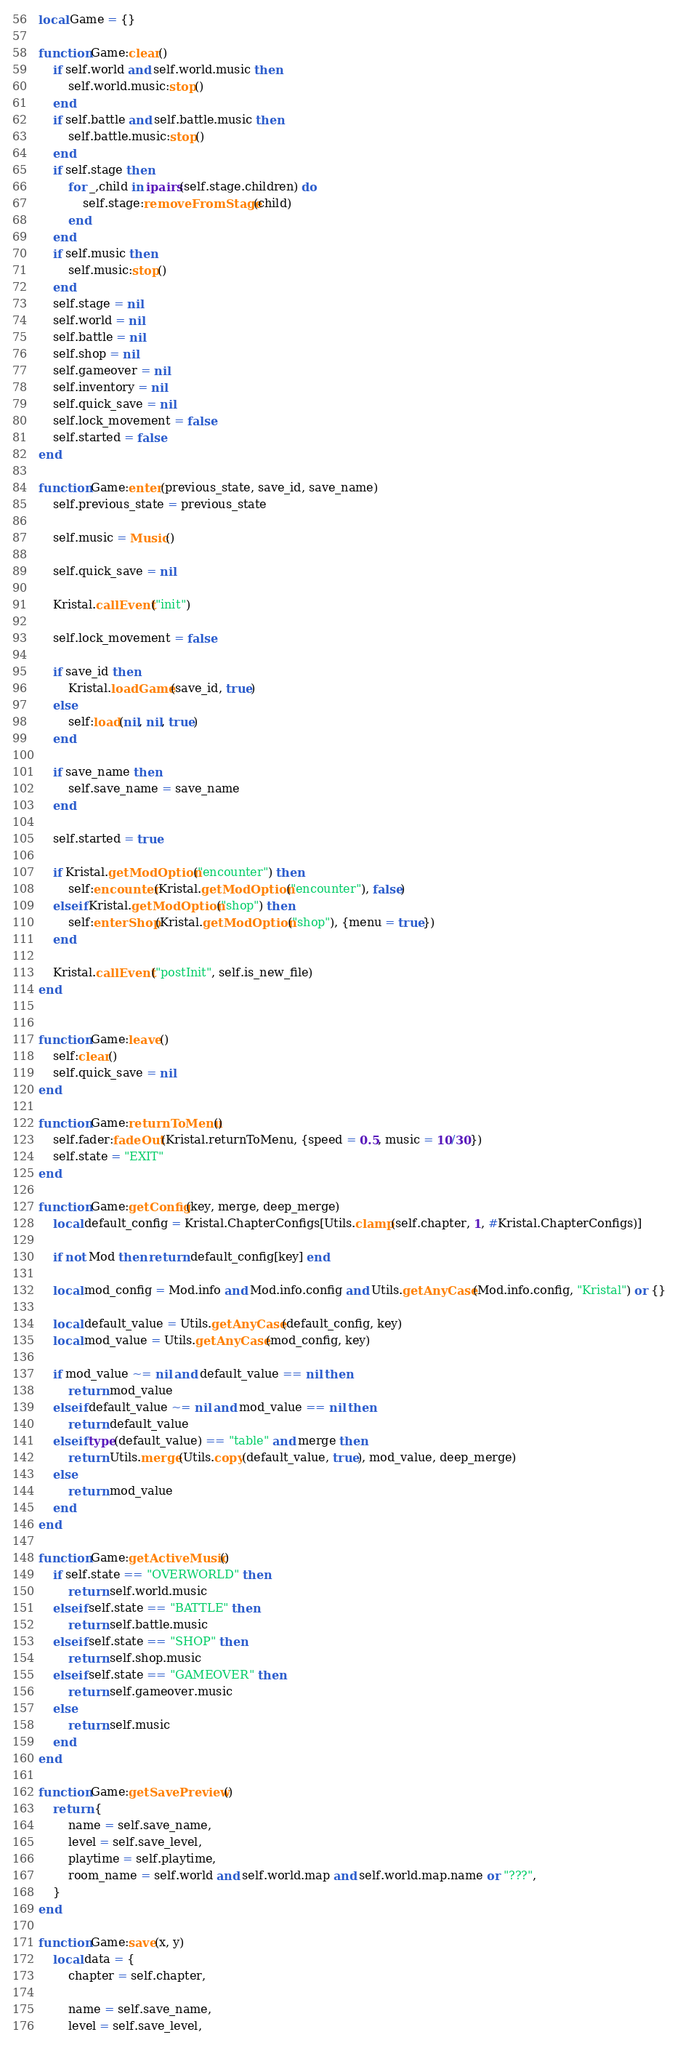<code> <loc_0><loc_0><loc_500><loc_500><_Lua_>local Game = {}

function Game:clear()
    if self.world and self.world.music then
        self.world.music:stop()
    end
    if self.battle and self.battle.music then
        self.battle.music:stop()
    end
    if self.stage then
        for _,child in ipairs(self.stage.children) do
            self.stage:removeFromStage(child)
        end
    end
    if self.music then
        self.music:stop()
    end
    self.stage = nil
    self.world = nil
    self.battle = nil
    self.shop = nil
    self.gameover = nil
    self.inventory = nil
    self.quick_save = nil
    self.lock_movement = false
    self.started = false
end

function Game:enter(previous_state, save_id, save_name)
    self.previous_state = previous_state

    self.music = Music()

    self.quick_save = nil

    Kristal.callEvent("init")

    self.lock_movement = false

    if save_id then
        Kristal.loadGame(save_id, true)
    else
        self:load(nil, nil, true)
    end

    if save_name then
        self.save_name = save_name
    end

    self.started = true

    if Kristal.getModOption("encounter") then
        self:encounter(Kristal.getModOption("encounter"), false)
    elseif Kristal.getModOption("shop") then
        self:enterShop(Kristal.getModOption("shop"), {menu = true})
    end

    Kristal.callEvent("postInit", self.is_new_file)
end


function Game:leave()
    self:clear()
    self.quick_save = nil
end

function Game:returnToMenu()
    self.fader:fadeOut(Kristal.returnToMenu, {speed = 0.5, music = 10/30})
    self.state = "EXIT"
end

function Game:getConfig(key, merge, deep_merge)
    local default_config = Kristal.ChapterConfigs[Utils.clamp(self.chapter, 1, #Kristal.ChapterConfigs)]

    if not Mod then return default_config[key] end

    local mod_config = Mod.info and Mod.info.config and Utils.getAnyCase(Mod.info.config, "Kristal") or {}

    local default_value = Utils.getAnyCase(default_config, key)
    local mod_value = Utils.getAnyCase(mod_config, key)

    if mod_value ~= nil and default_value == nil then
        return mod_value
    elseif default_value ~= nil and mod_value == nil then
        return default_value
    elseif type(default_value) == "table" and merge then
        return Utils.merge(Utils.copy(default_value, true), mod_value, deep_merge)
    else
        return mod_value
    end
end

function Game:getActiveMusic()
    if self.state == "OVERWORLD" then
        return self.world.music
    elseif self.state == "BATTLE" then
        return self.battle.music
    elseif self.state == "SHOP" then
        return self.shop.music
    elseif self.state == "GAMEOVER" then
        return self.gameover.music
    else
        return self.music
    end
end

function Game:getSavePreview()
    return {
        name = self.save_name,
        level = self.save_level,
        playtime = self.playtime,
        room_name = self.world and self.world.map and self.world.map.name or "???",
    }
end

function Game:save(x, y)
    local data = {
        chapter = self.chapter,

        name = self.save_name,
        level = self.save_level,</code> 